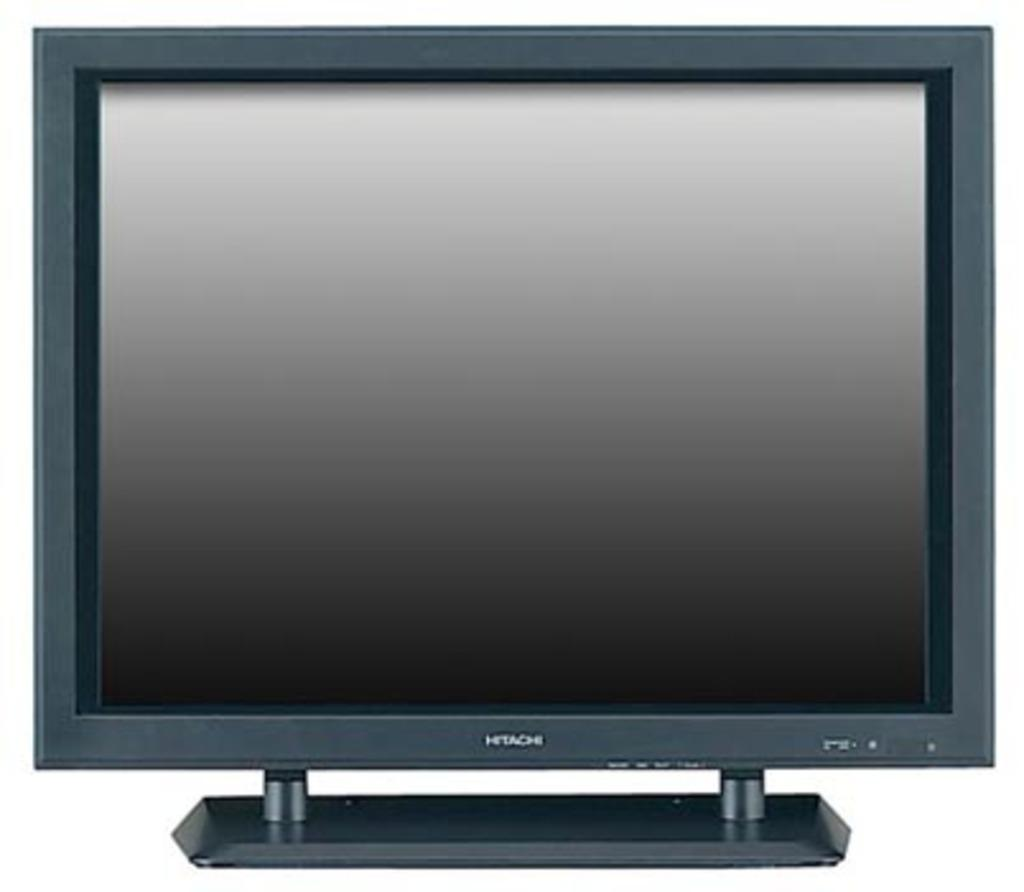Provide a one-sentence caption for the provided image. A Hitachi TV is turned off and the screen is dark. 